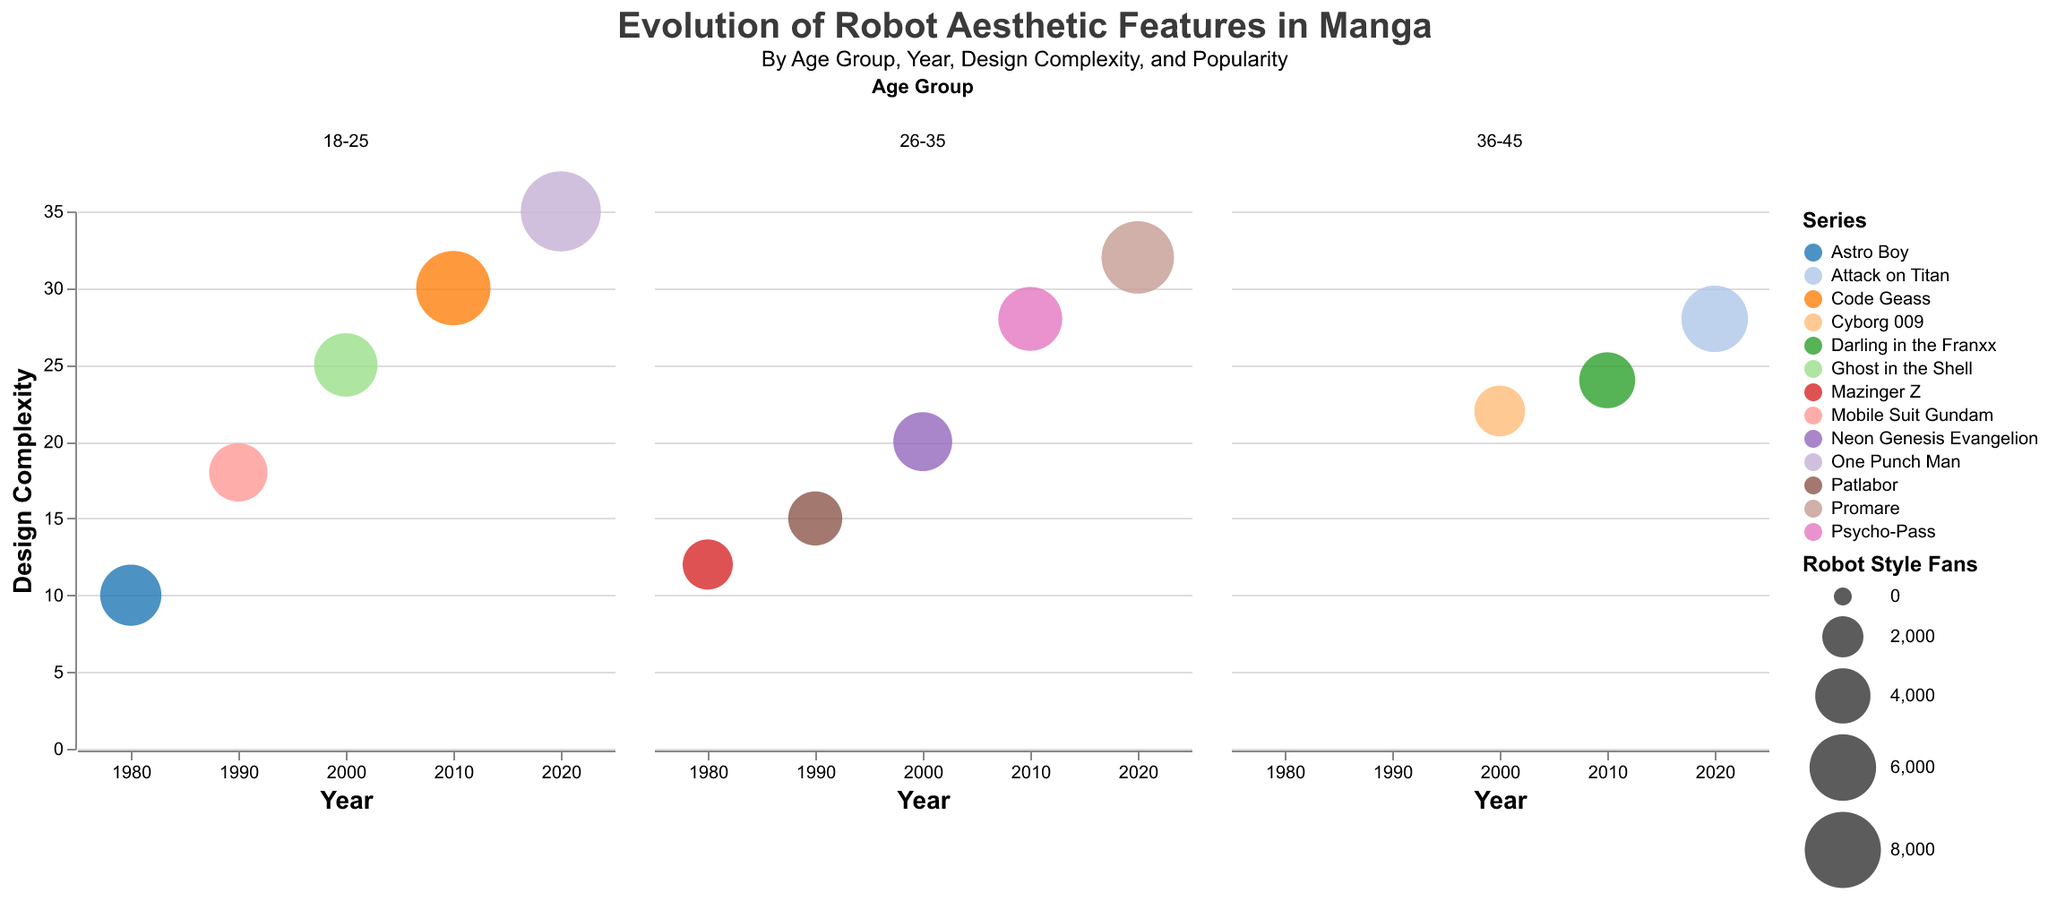What is the title and subtitle of the figure? The title and subtitle of the figure can be directly observed at the top of the plot. They provide context about what the figure represents.
Answer: "Evolution of Robot Aesthetic Features in Manga" and "By Age Group, Year, Design Complexity, and Popularity" Which age group had the highest number of robot style fans in 2020? In the 2020 subplot, the 18-25 age group has the largest bubble, indicating the highest number of robot style fans.
Answer: 18-25 How does the design complexity trend for the series in the 18-25 age group from 1980 to 2020? By examining the vertical position of the bubbles for the 18-25 age group across the subplots, you can observe that the design complexity increases over the decades.
Answer: Increases What series had the most fans in 2010 for the 26-35 age group? Check the 2010 subplot under the 26-35 age group and observe which bubble is the largest. In this case, it is Psycho-Pass.
Answer: Psycho-Pass What is the design complexity for "Mobile Suit Gundam" in 1990 and how does it compare to "Patlabor" in the same year? Look at the 1990 subplot under both Mobile Suit Gundam and Patlabor. The vertical positions indicate the design complexity values. Mobile Suit Gundam has a design complexity of 18, and Patlabor has a design complexity of 15.
Answer: Mobile Suit Gundam: 18, Patlabor: 15 Between 1990 and 2020, which age group shows the highest increase in robot style fans? By comparing the bubbles' sizes for each age group from 1990 to 2020, the 18-25 age group's bubble increases the most significantly in size.
Answer: 18-25 What are the colors used to represent "Neon Genesis Evangelion" and "Attack on Titan"? In the legend, the colors associated with each series are displayed. Neon Genesis Evangelion has its specific color, and so does Attack on Titan.
Answer: Neon Genesis Evangelion: color A, Attack on Titan: color B (use the visual color provided in the figure) What is the average design complexity for all series in 2010? Sum the design complexities of all series for 2010 and divide by the total number of series. For 2010: (30 + 28 + 24)/3 = 82/3 = 27.33
Answer: 27.33 Which series in the 36-45 age group in 2000 has the highest design complexity? In the 2000 subplot under the 36-45 age group, observe which bubble is the highest. Cyborg 009 is the highest.
Answer: Cyborg 009 How many series are represented in the 2010 age group 18-25 subplot? Count the number of distinct bubbles within the 2010 age group 18-25 subplot. There is only one bubble represented.
Answer: 1 